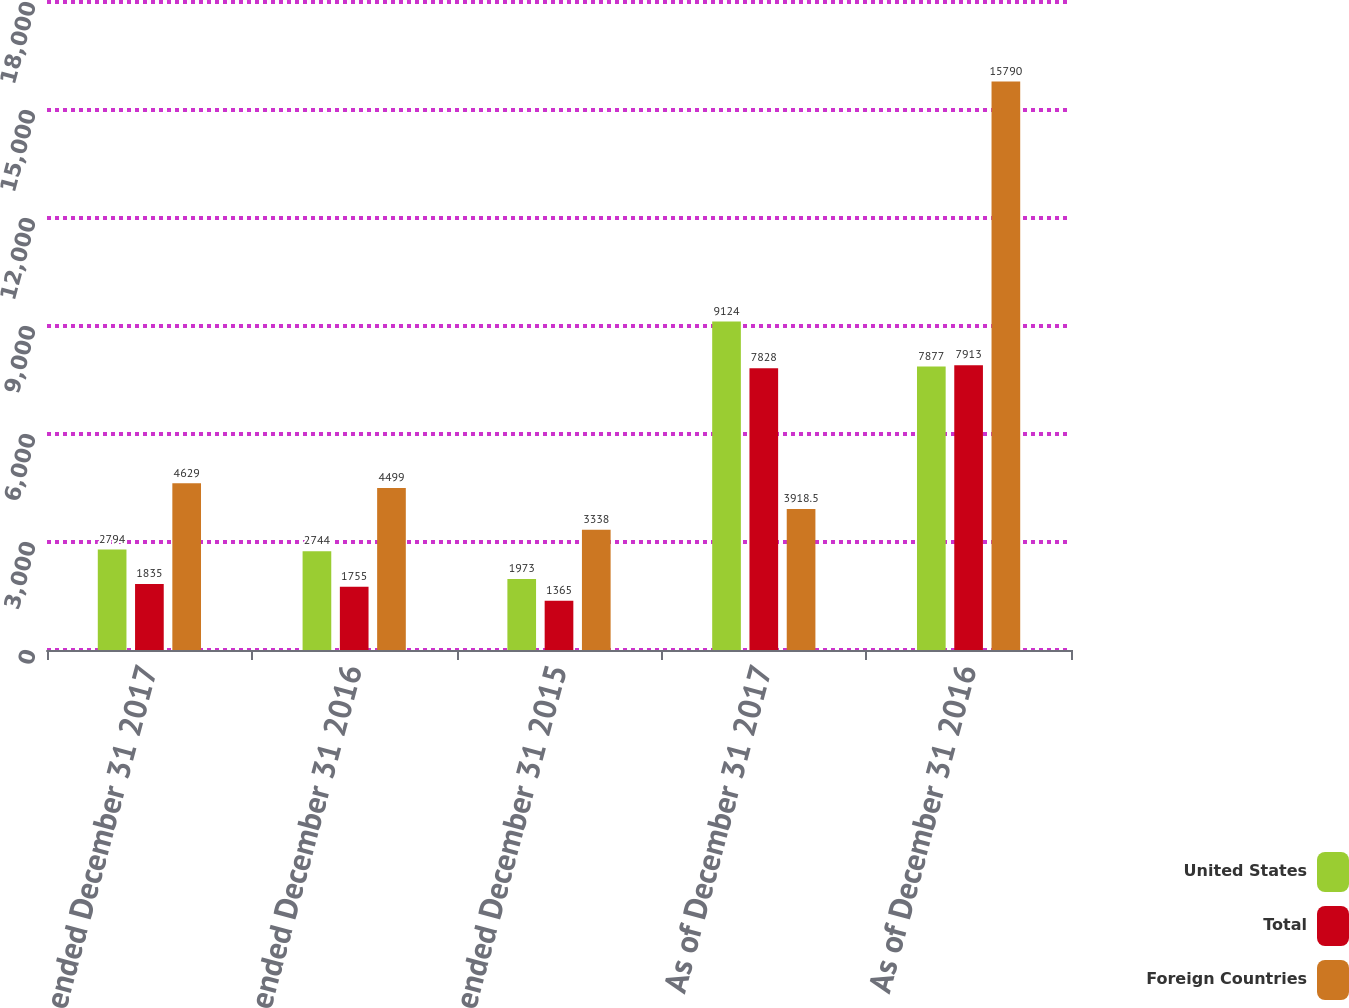<chart> <loc_0><loc_0><loc_500><loc_500><stacked_bar_chart><ecel><fcel>Year ended December 31 2017<fcel>Year ended December 31 2016<fcel>Year ended December 31 2015<fcel>As of December 31 2017<fcel>As of December 31 2016<nl><fcel>United States<fcel>2794<fcel>2744<fcel>1973<fcel>9124<fcel>7877<nl><fcel>Total<fcel>1835<fcel>1755<fcel>1365<fcel>7828<fcel>7913<nl><fcel>Foreign Countries<fcel>4629<fcel>4499<fcel>3338<fcel>3918.5<fcel>15790<nl></chart> 